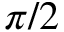Convert formula to latex. <formula><loc_0><loc_0><loc_500><loc_500>\pi / 2</formula> 